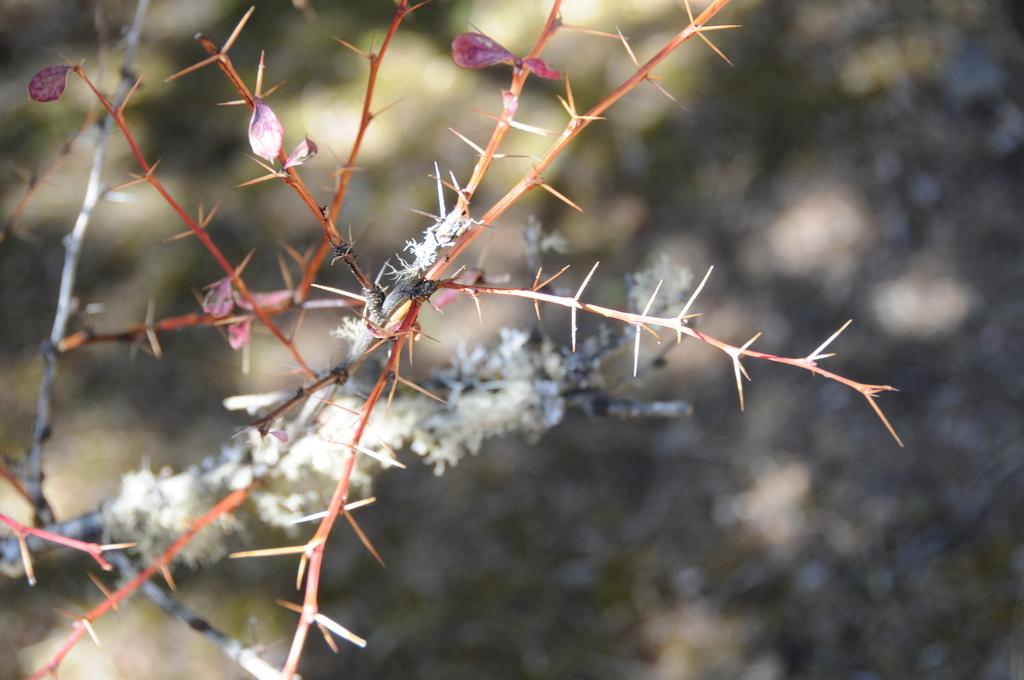What type of plant is depicted in the image? The image shows stems with thorns. What can be seen on the stems? There are white color objects on the stems. Can you describe the background of the image? The background of the image is blurred. How many attempts were made to grip the stems in the image? There is no indication in the image of any attempts being made to grip the stems. 